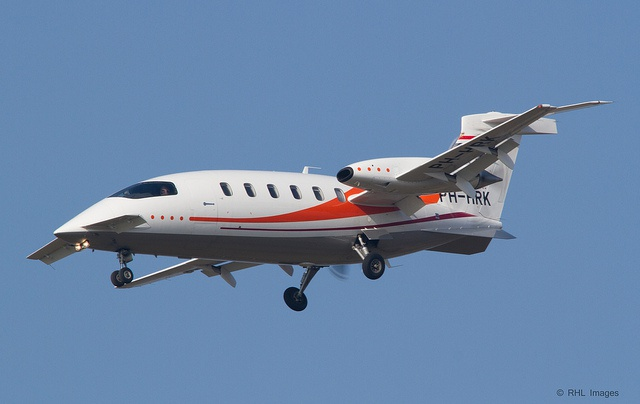Describe the objects in this image and their specific colors. I can see a airplane in gray, black, lightgray, and darkgray tones in this image. 